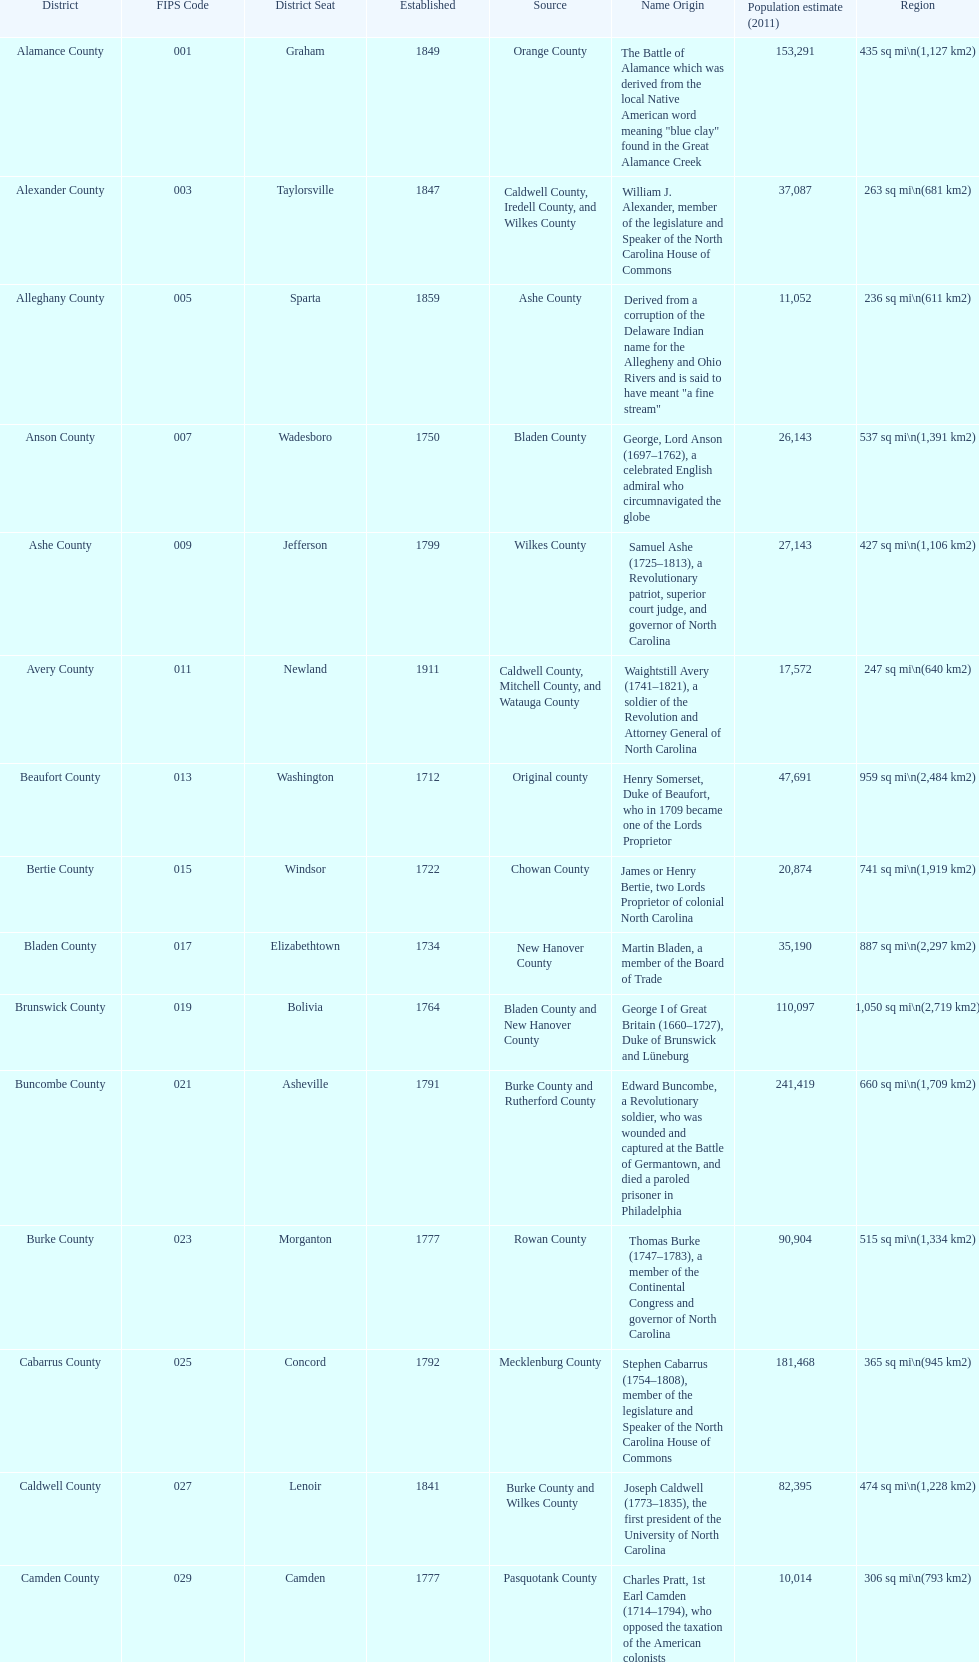Which county covers the most area? Dare County. 